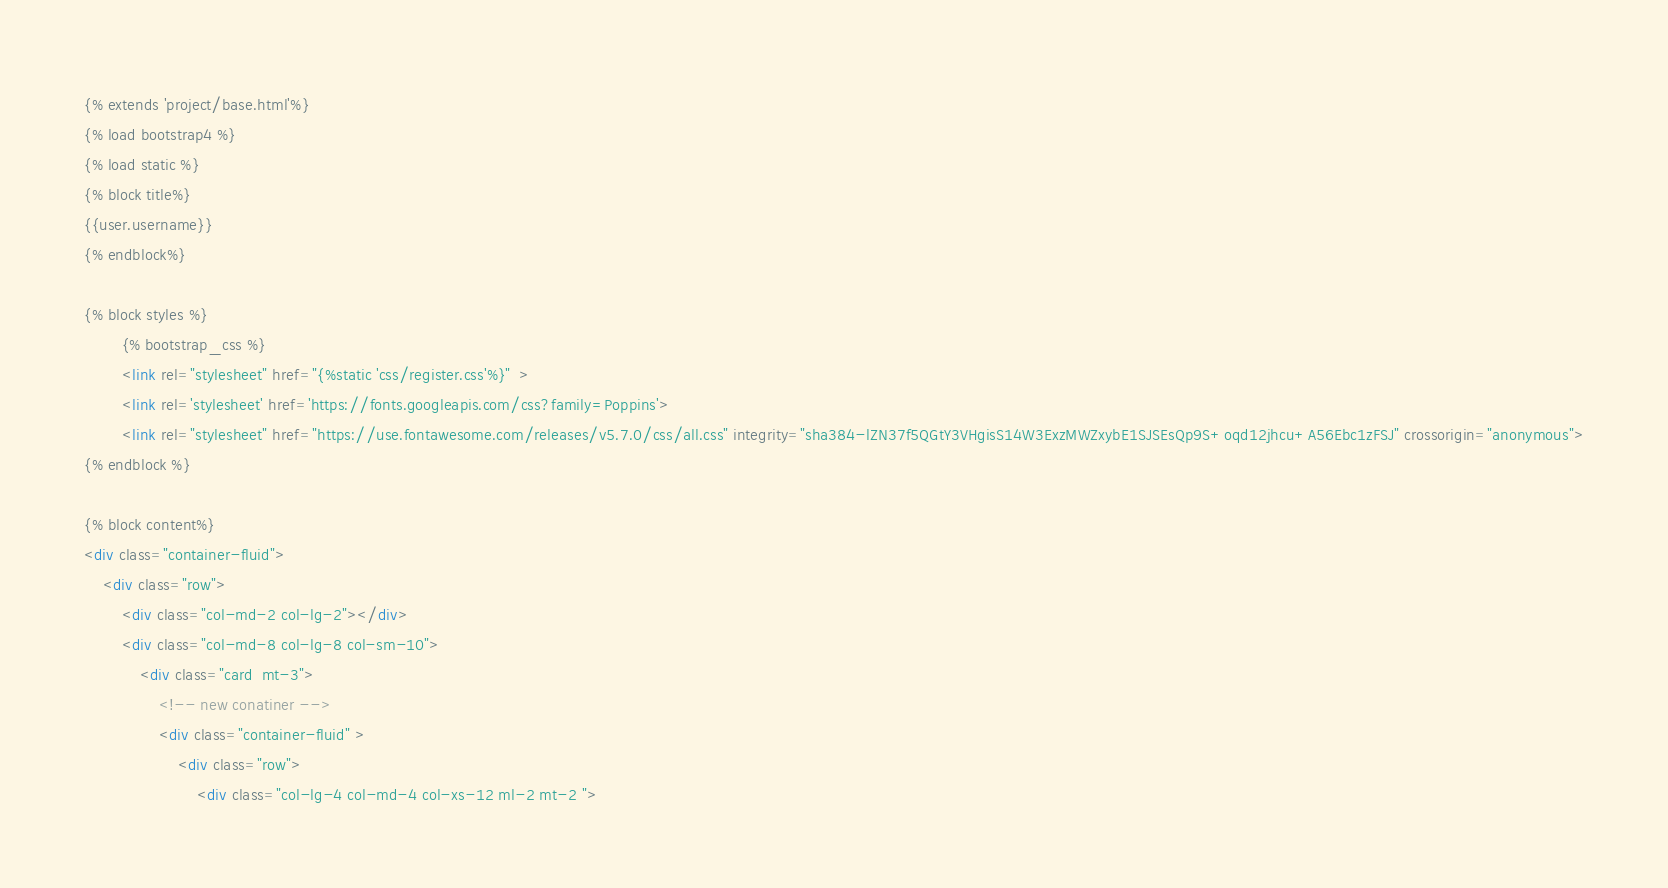<code> <loc_0><loc_0><loc_500><loc_500><_HTML_>{% extends 'project/base.html'%}
{% load bootstrap4 %} 
{% load static %}
{% block title%}
{{user.username}}
{% endblock%}

{% block styles %}
        {% bootstrap_css %}
        <link rel="stylesheet" href="{%static 'css/register.css'%}"  >
        <link rel='stylesheet' href='https://fonts.googleapis.com/css?family=Poppins'>
        <link rel="stylesheet" href="https://use.fontawesome.com/releases/v5.7.0/css/all.css" integrity="sha384-lZN37f5QGtY3VHgisS14W3ExzMWZxybE1SJSEsQp9S+oqd12jhcu+A56Ebc1zFSJ" crossorigin="anonymous">
{% endblock %}

{% block content%}
<div class="container-fluid">
    <div class="row">
        <div class="col-md-2 col-lg-2"></div>
        <div class="col-md-8 col-lg-8 col-sm-10">
            <div class="card  mt-3">
                <!-- new conatiner -->
                <div class="container-fluid" >
                    <div class="row">
                        <div class="col-lg-4 col-md-4 col-xs-12 ml-2 mt-2 "></code> 